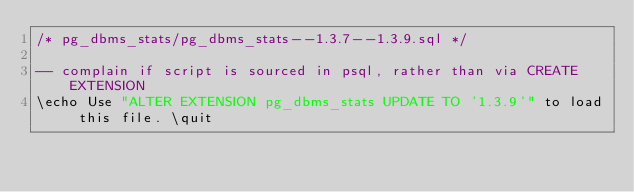Convert code to text. <code><loc_0><loc_0><loc_500><loc_500><_SQL_>/* pg_dbms_stats/pg_dbms_stats--1.3.7--1.3.9.sql */

-- complain if script is sourced in psql, rather than via CREATE EXTENSION
\echo Use "ALTER EXTENSION pg_dbms_stats UPDATE TO '1.3.9'" to load this file. \quit
</code> 